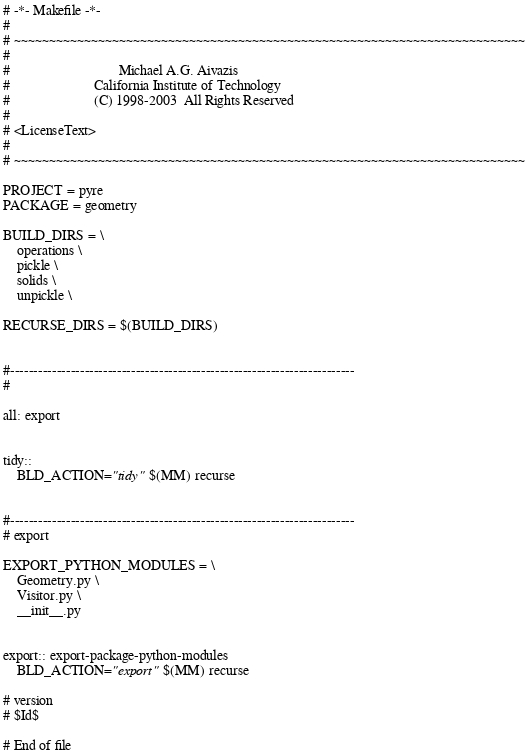<code> <loc_0><loc_0><loc_500><loc_500><_ObjectiveC_># -*- Makefile -*-
#
# ~~~~~~~~~~~~~~~~~~~~~~~~~~~~~~~~~~~~~~~~~~~~~~~~~~~~~~~~~~~~~~~~~~~~~~~~~
#
#                               Michael A.G. Aivazis
#                        California Institute of Technology
#                        (C) 1998-2003  All Rights Reserved
#
# <LicenseText>
#
# ~~~~~~~~~~~~~~~~~~~~~~~~~~~~~~~~~~~~~~~~~~~~~~~~~~~~~~~~~~~~~~~~~~~~~~~~~

PROJECT = pyre
PACKAGE = geometry

BUILD_DIRS = \
    operations \
    pickle \
    solids \
    unpickle \

RECURSE_DIRS = $(BUILD_DIRS)


#--------------------------------------------------------------------------
#

all: export


tidy::
	BLD_ACTION="tidy" $(MM) recurse


#--------------------------------------------------------------------------
# export

EXPORT_PYTHON_MODULES = \
    Geometry.py \
    Visitor.py \
    __init__.py


export:: export-package-python-modules
	BLD_ACTION="export" $(MM) recurse

# version
# $Id$

# End of file
</code> 